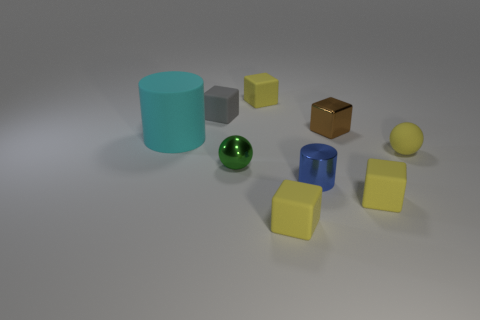Is there anything in the image that might tell us about the scale of the objects? The scale of the objects is difficult to determine with certainty as there are no familiar reference points to compare with. However, the shadows and object comparisons suggest a plausible size relationship; for instance, by estimating the smaller and larger cylinders’ height relation or comparing the yellow spheres, we might infer that these are not life-sized objects but rather models or miniatures. 